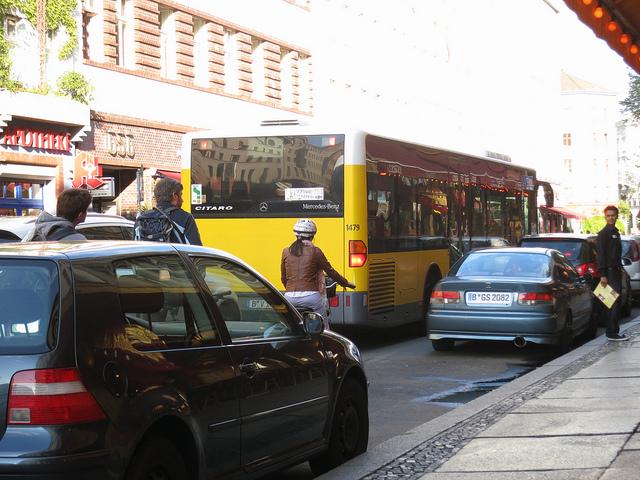What color is the bus?
Write a very short answer. Yellow. How many people are not in a vehicle?
Keep it brief. 4. Where is this?
Be succinct. City. 